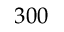<formula> <loc_0><loc_0><loc_500><loc_500>3 0 0</formula> 